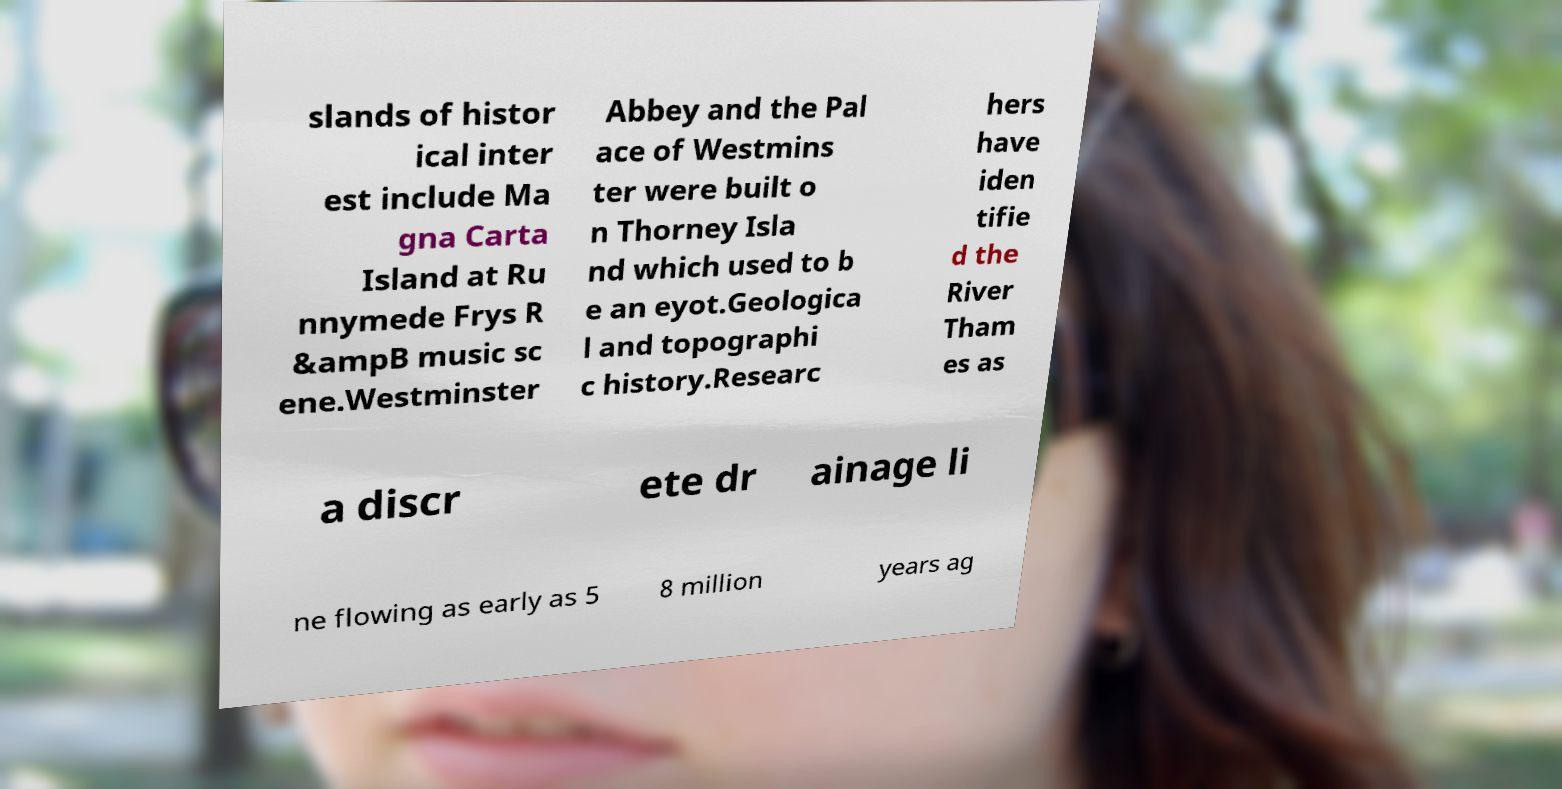Can you read and provide the text displayed in the image?This photo seems to have some interesting text. Can you extract and type it out for me? slands of histor ical inter est include Ma gna Carta Island at Ru nnymede Frys R &ampB music sc ene.Westminster Abbey and the Pal ace of Westmins ter were built o n Thorney Isla nd which used to b e an eyot.Geologica l and topographi c history.Researc hers have iden tifie d the River Tham es as a discr ete dr ainage li ne flowing as early as 5 8 million years ag 